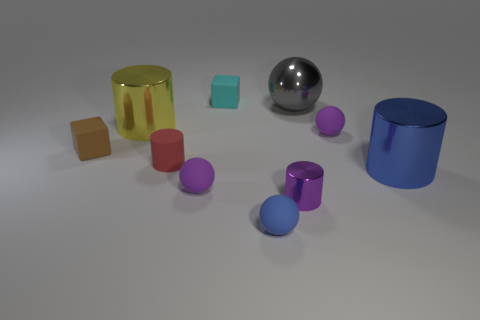Subtract 1 cylinders. How many cylinders are left? 3 Subtract all cylinders. How many objects are left? 6 Subtract 0 red spheres. How many objects are left? 10 Subtract all red cubes. Subtract all large gray metal balls. How many objects are left? 9 Add 1 big blue objects. How many big blue objects are left? 2 Add 6 large purple metallic cylinders. How many large purple metallic cylinders exist? 6 